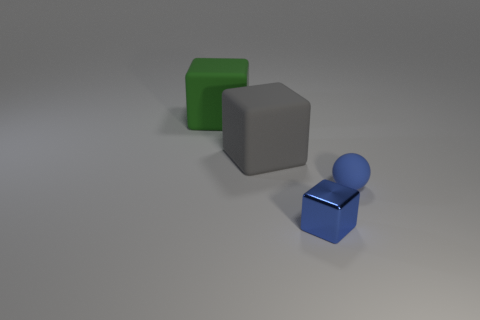Is the number of blue metal objects greater than the number of big blocks?
Your answer should be compact. No. What shape is the matte object that is on the right side of the tiny object to the left of the tiny blue rubber sphere?
Provide a short and direct response. Sphere. Is the tiny rubber sphere the same color as the metal block?
Offer a terse response. Yes. Is the number of blue spheres to the right of the big gray matte object greater than the number of small green cubes?
Give a very brief answer. Yes. What number of tiny blue cubes are in front of the blue thing to the right of the small blue shiny thing?
Your answer should be very brief. 1. Are the block left of the gray rubber cube and the object that is in front of the blue matte sphere made of the same material?
Provide a short and direct response. No. There is a sphere that is the same color as the tiny metal thing; what material is it?
Your answer should be very brief. Rubber. What number of metal things are the same shape as the gray matte thing?
Provide a succinct answer. 1. Do the gray object and the object that is in front of the small sphere have the same material?
Your answer should be compact. No. There is a cube that is the same size as the green object; what is it made of?
Give a very brief answer. Rubber. 